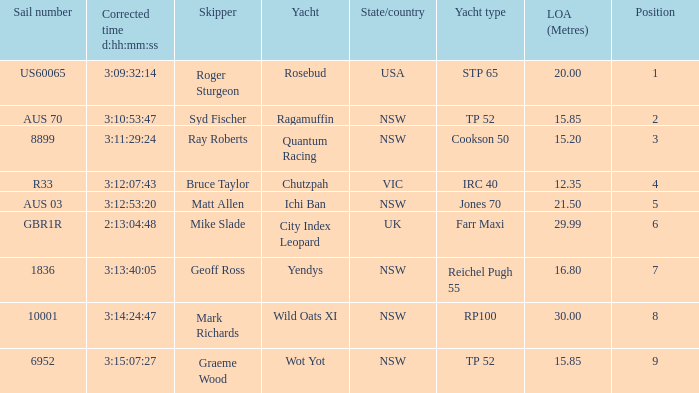What are all of the states or countries with a corrected time 3:13:40:05? NSW. 